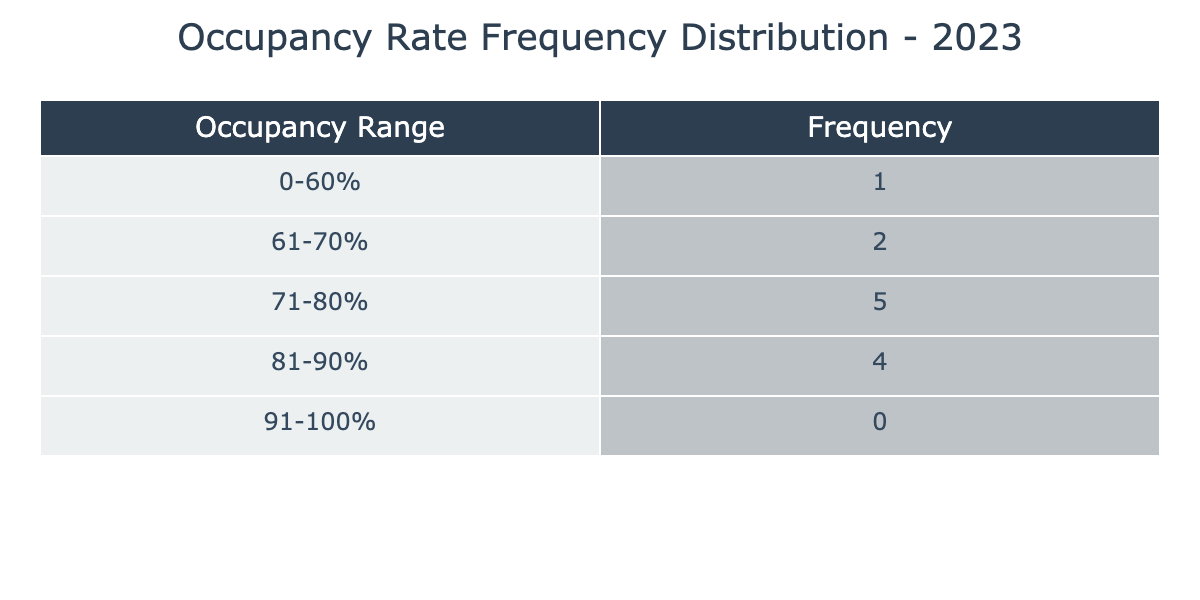What is the highest occupancy rate recorded in a month? Looking at the occupancy rates for each month, the highest value is in June with an occupancy rate of 90%.
Answer: 90% Which month had the lowest occupancy rate? The occupancy rate data shows that December had the lowest rate at 60%.
Answer: December How many months had an occupancy rate of over 80%? The months of April, May, June, and July all have occupancy rates over 80%, making a total of four months.
Answer: 4 What is the average occupancy rate for the first quarter (January to March)? The occupancy rates for January (72), February (68), and March (75) sum up to 215. Dividing by 3 gives an average of 71.67.
Answer: 71.67 Is there a month with an occupancy rate below 70%? Yes, December has an occupancy rate of 60%, which is below 70%.
Answer: Yes How many months had an occupancy rate between 71% and 80%? The months that meet this criteria are January (72), March (75), and November (74), totaling three months.
Answer: 3 What is the difference in occupancy rates between the highest and lowest months? The highest occupancy rate is in June (90%) and the lowest is in December (60%). The difference is 90 - 60 = 30.
Answer: 30 Which occupancy range has the most months within it? The range from 81-90% has four months (April, May, June, July) that fall within it, which is the most compared to other ranges.
Answer: 81-90% Was there any month that saw an occupancy rate below 65%? No, the lowest rate recorded was 60% in December, which is below 65%.
Answer: No 